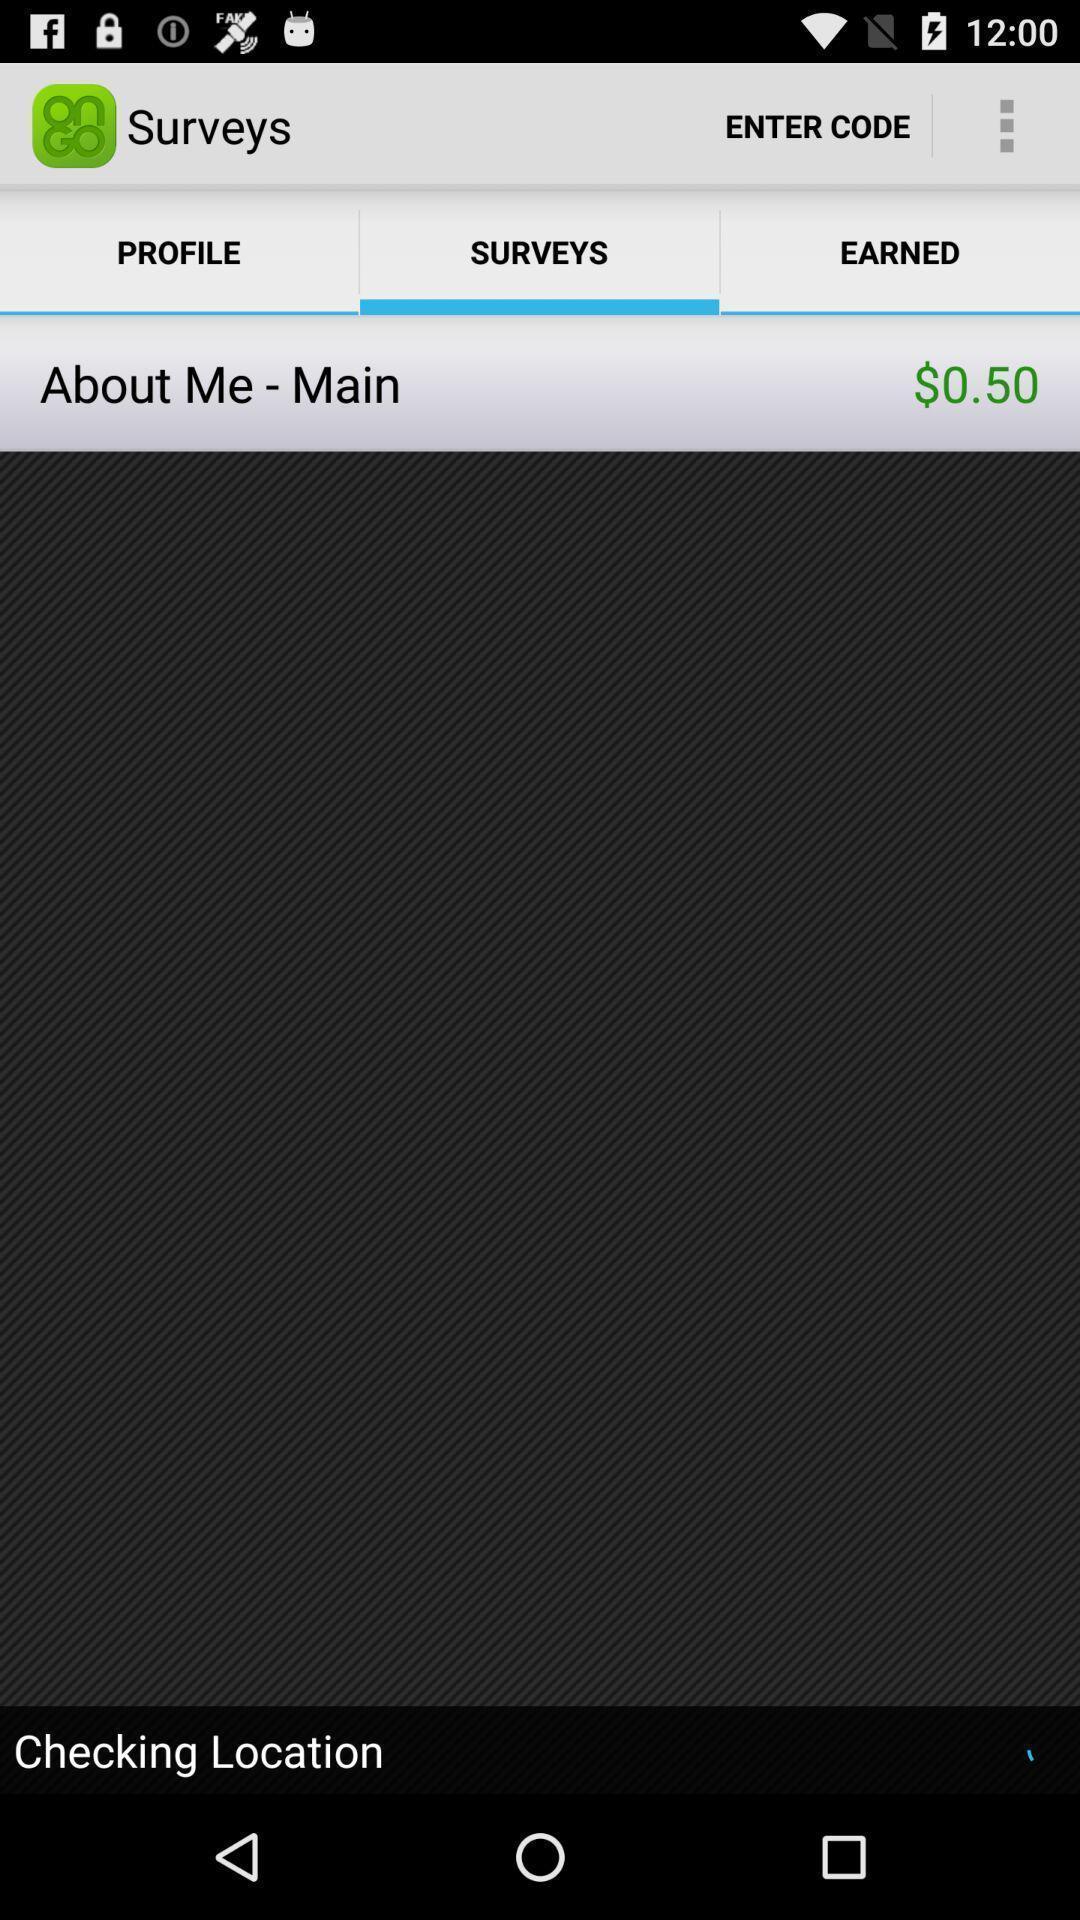Explain the elements present in this screenshot. Surveys tab in the application. 